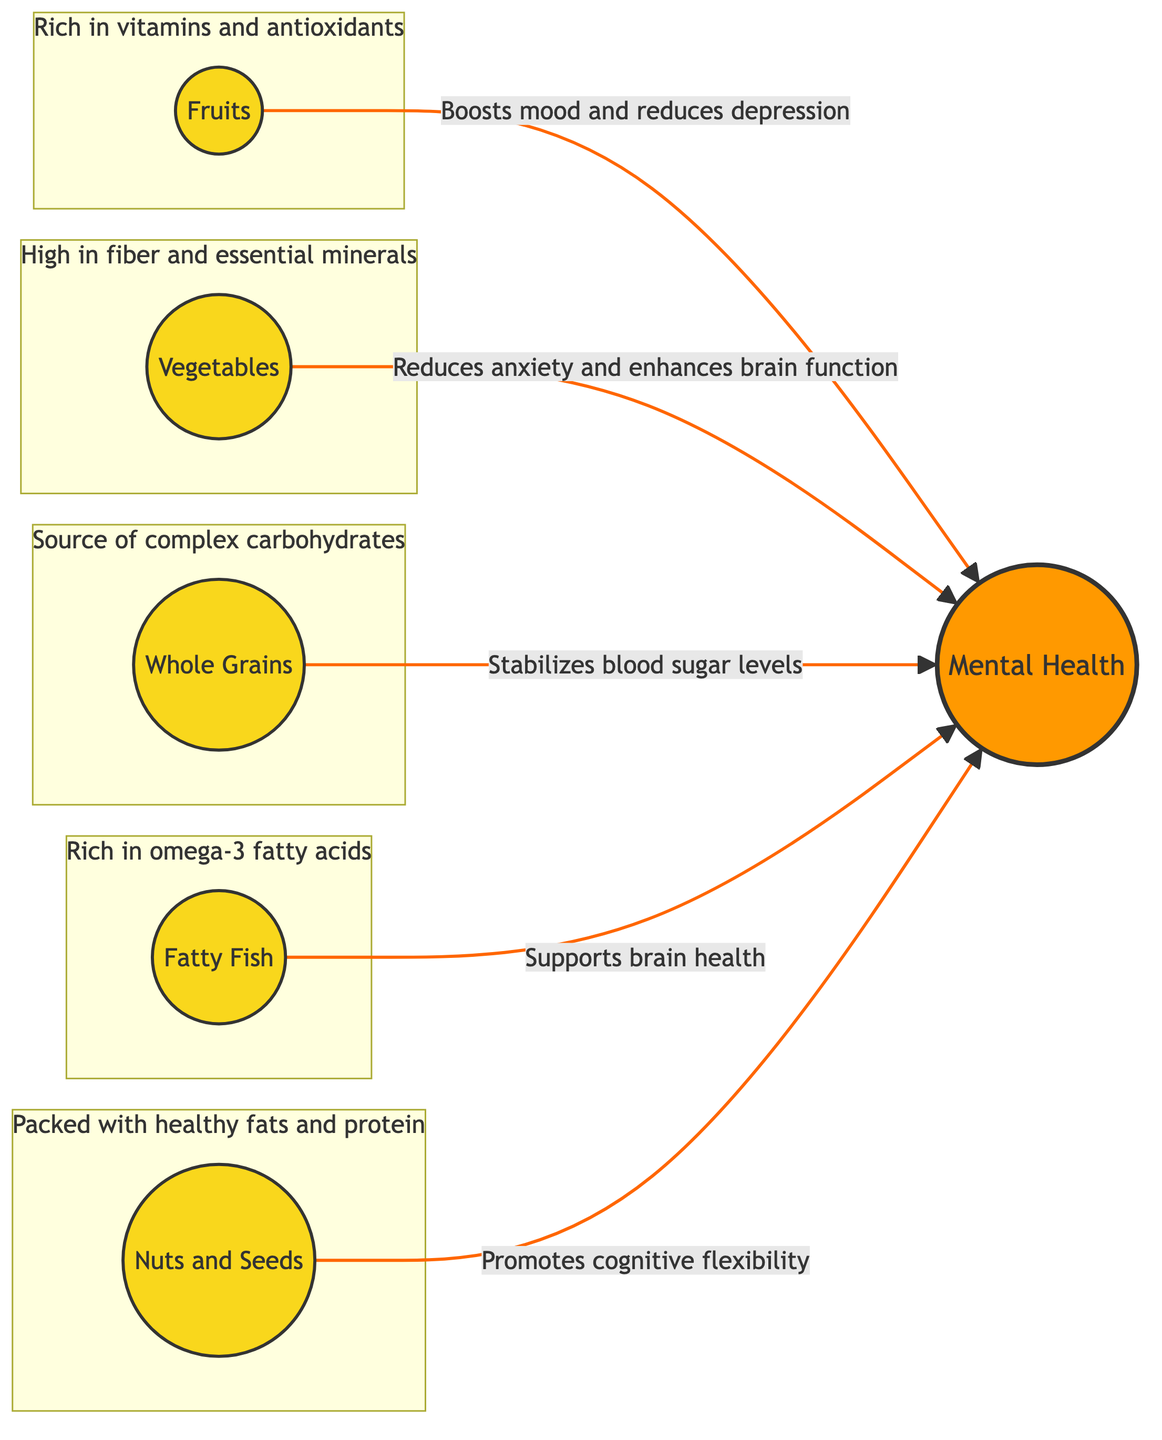What is the central node in the diagram? The central node in the diagram is labeled "Mental Health," which is the primary focus of the relationships shown between the various food groups.
Answer: Mental Health How many food groups are connected to the central node? There are five food groups connected to the central node, which include Fruits, Vegetables, Whole Grains, Fatty Fish, and Nuts and Seeds.
Answer: 5 Which food group supports brain health? The food group that supports brain health is labeled "Fatty Fish," as indicated in the connection to the central node, "Mental Health."
Answer: Fatty Fish What benefit do vegetables provide according to the diagram? The diagram states that vegetables reduce anxiety and enhance brain function, which shows their positive impact on mental health.
Answer: Reduces anxiety and enhances brain function Which food group is rich in omega-3 fatty acids? The food group identified as rich in omega-3 fatty acids is "Fatty Fish," which is crucial for supporting brain health as shown in the diagram.
Answer: Fatty Fish What is the common characteristic of the food groups in the subgraph Fruits? The subgraph indicating Fruits mentions that they are rich in vitamins and antioxidants, highlighting their nutritional benefits.
Answer: Rich in vitamins and antioxidants Which food group stabilizes blood sugar levels? According to the diagram, "Whole Grains" is the food group that stabilizes blood sugar levels, contributing to overall mental health.
Answer: Whole Grains Why is the connection style for the edges colored orange? The connection style is colored orange to visually distinguish the relationships between the food groups and mental health, emphasizing their importance.
Answer: Orange What type of nutrients do nuts and seeds provide? The diagram states that nuts and seeds are packed with healthy fats and protein, which are beneficial for cognitive flexibility and mental health.
Answer: Healthy fats and protein 